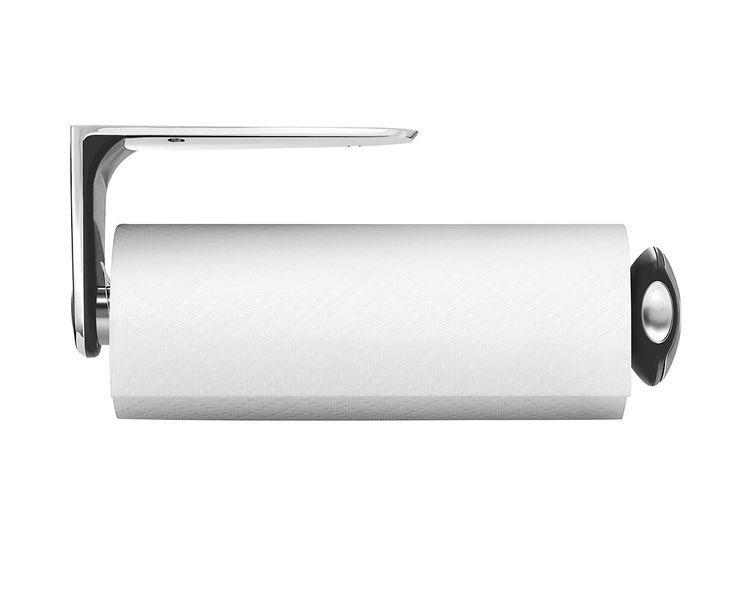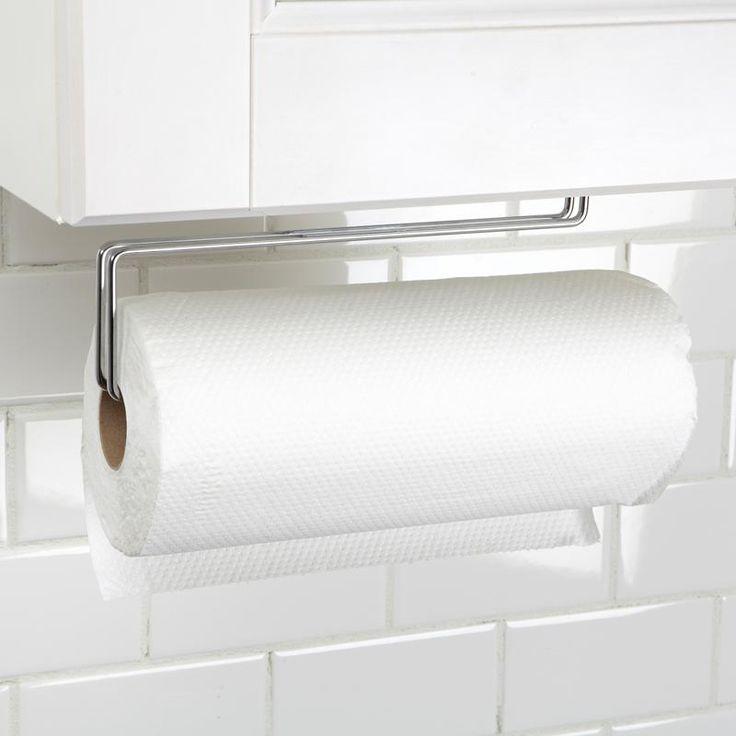The first image is the image on the left, the second image is the image on the right. Analyze the images presented: Is the assertion "Each image shows a white paper roll hung on a dispenser." valid? Answer yes or no. Yes. The first image is the image on the left, the second image is the image on the right. For the images shown, is this caption "Each roll of toilet paper is hanging on a dispenser." true? Answer yes or no. Yes. 